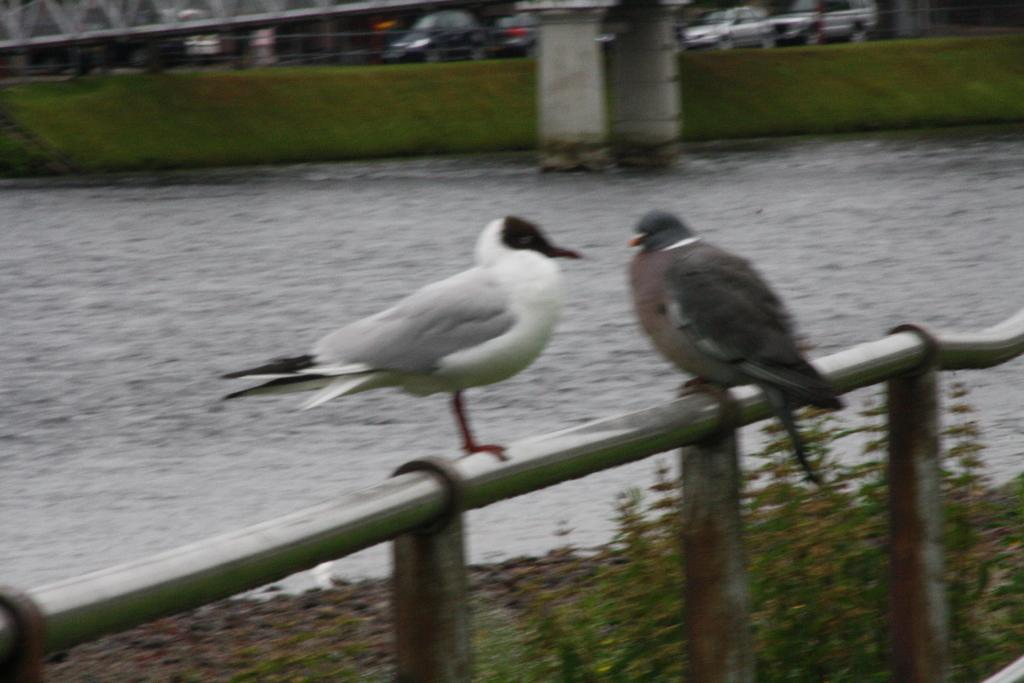How many birds can be seen in the image? There are two birds in the image. Where are the birds located? The birds are standing on a fence. What type of natural elements are present in the image? There are trees in the image. What architectural features can be seen in the image? There are pillars in the image. What is the water feature in the image? Water is visible in the image. What can be seen in the background of the image? Vehicles are present in the background of the image. What type of ornament is hanging from the bird's beak in the image? There is no ornament hanging from the bird's beak in the image; the birds are simply standing on the fence. Can you tell me the name of the boy who is playing with the birds in the image? There is no boy present in the image; it only features two birds standing on a fence. 